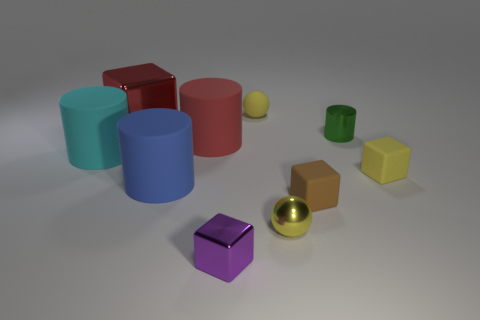Are there more tiny purple metallic blocks that are on the left side of the blue matte cylinder than green cylinders?
Your response must be concise. No. Are there any tiny cylinders that have the same color as the big metallic cube?
Keep it short and to the point. No. There is another ball that is the same size as the yellow metal sphere; what color is it?
Your answer should be compact. Yellow. There is a cylinder that is left of the large blue cylinder; how many big rubber cylinders are in front of it?
Your answer should be compact. 1. What number of objects are tiny matte objects behind the yellow cube or big red rubber cylinders?
Your answer should be very brief. 2. What number of small cylinders have the same material as the green thing?
Make the answer very short. 0. What shape is the rubber object that is the same color as the large shiny object?
Your response must be concise. Cylinder. Are there an equal number of small yellow shiny objects in front of the big red rubber object and cyan rubber objects?
Your answer should be compact. Yes. There is a object in front of the tiny metallic sphere; how big is it?
Your answer should be very brief. Small. What number of small things are yellow balls or cyan rubber cylinders?
Your answer should be compact. 2. 